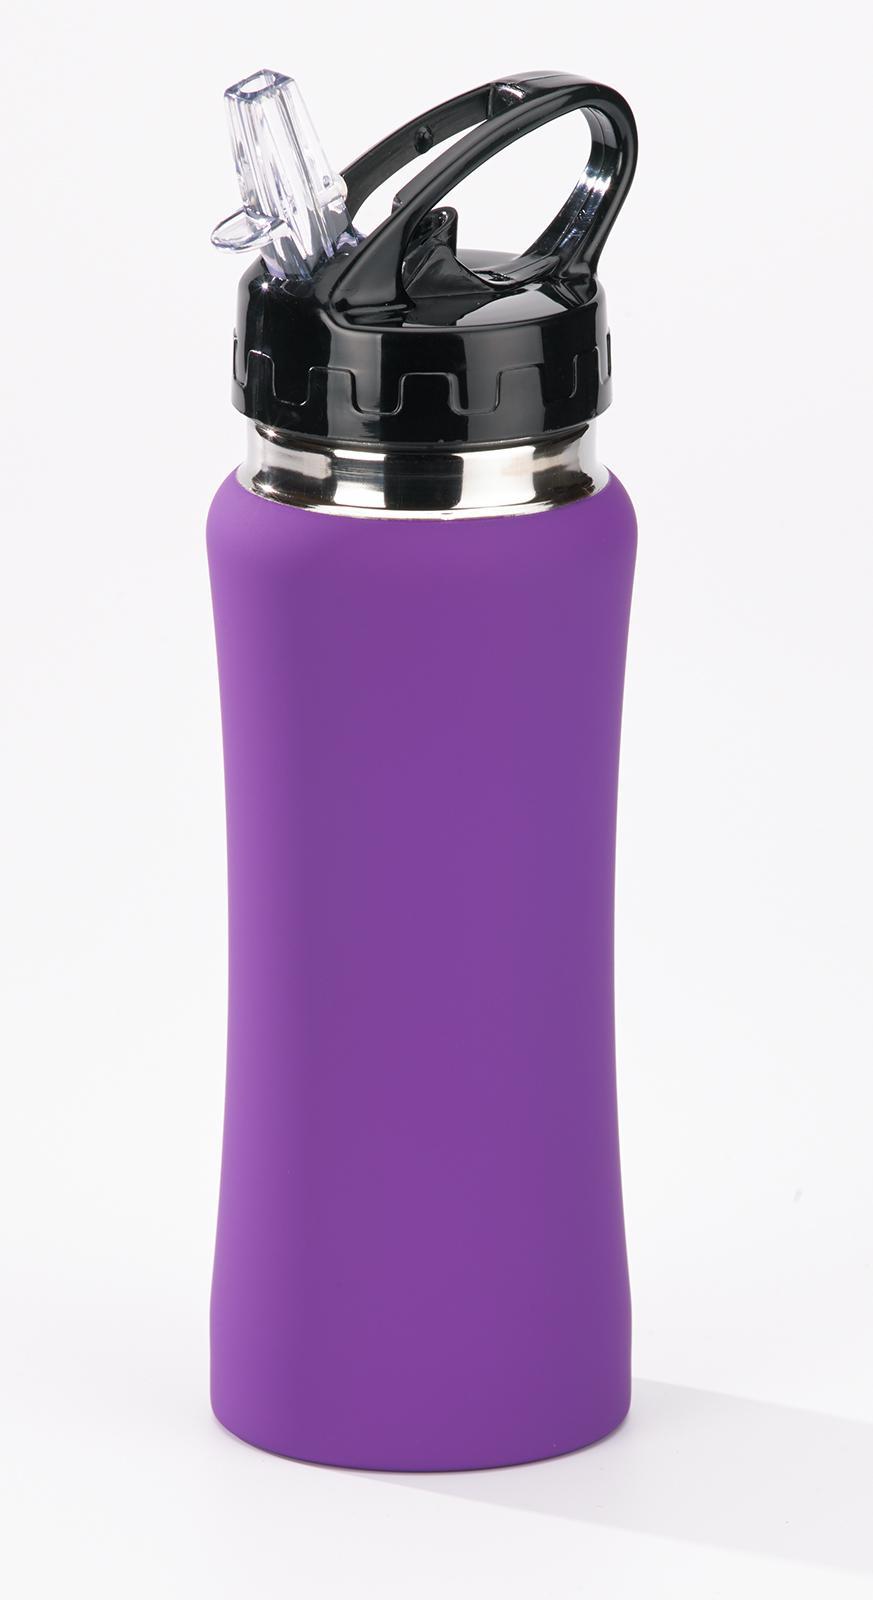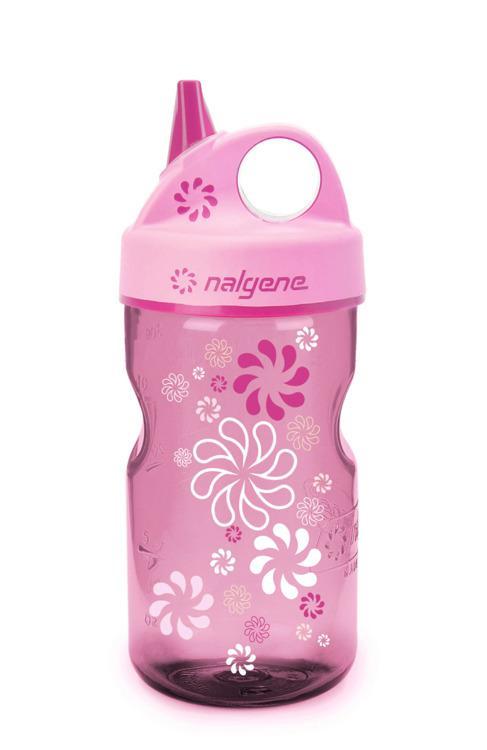The first image is the image on the left, the second image is the image on the right. Considering the images on both sides, is "In at least one image there is a red bottle in front of a box with an engraved package on it." valid? Answer yes or no. No. The first image is the image on the left, the second image is the image on the right. Examine the images to the left and right. Is the description "The combined images include a white upright box with a sketch of a gift box on it and a red water bottle." accurate? Answer yes or no. No. 